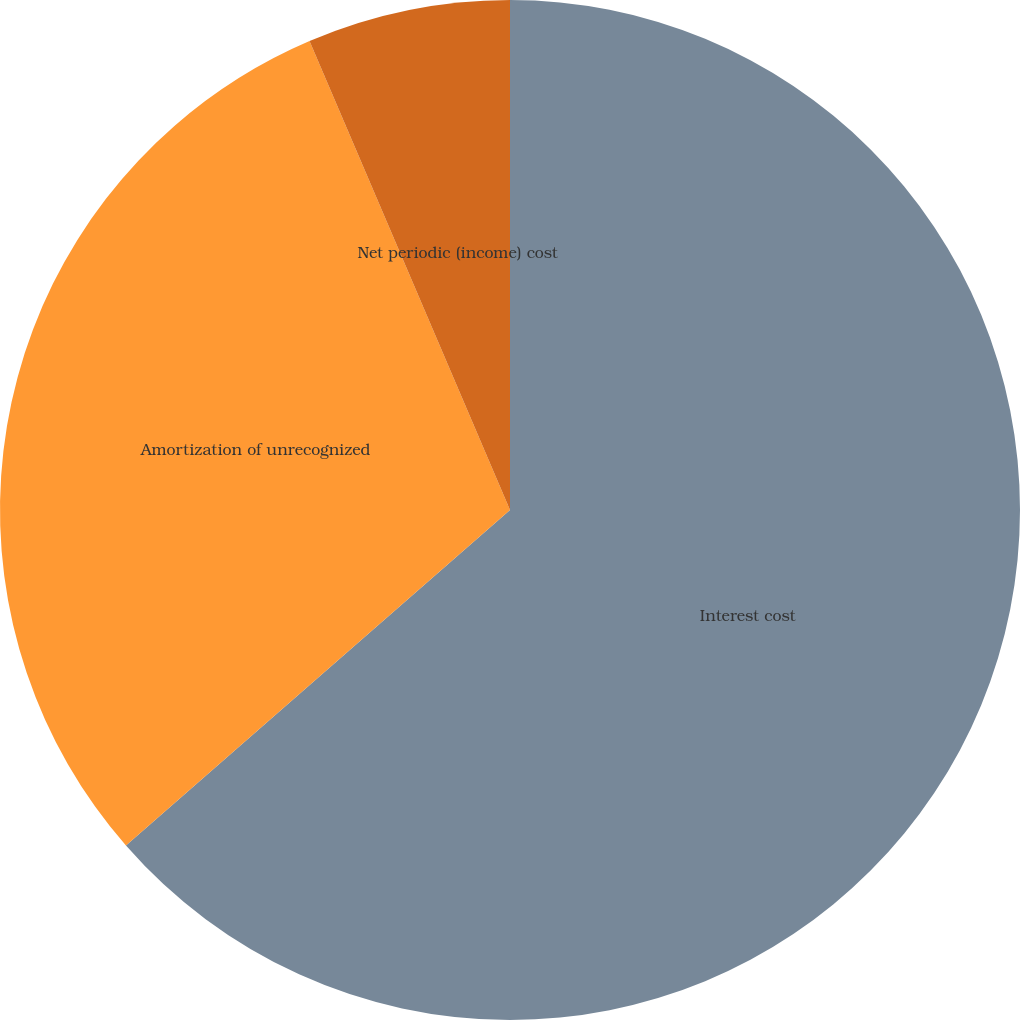<chart> <loc_0><loc_0><loc_500><loc_500><pie_chart><fcel>Interest cost<fcel>Amortization of unrecognized<fcel>Net periodic (income) cost<nl><fcel>63.57%<fcel>30.0%<fcel>6.43%<nl></chart> 